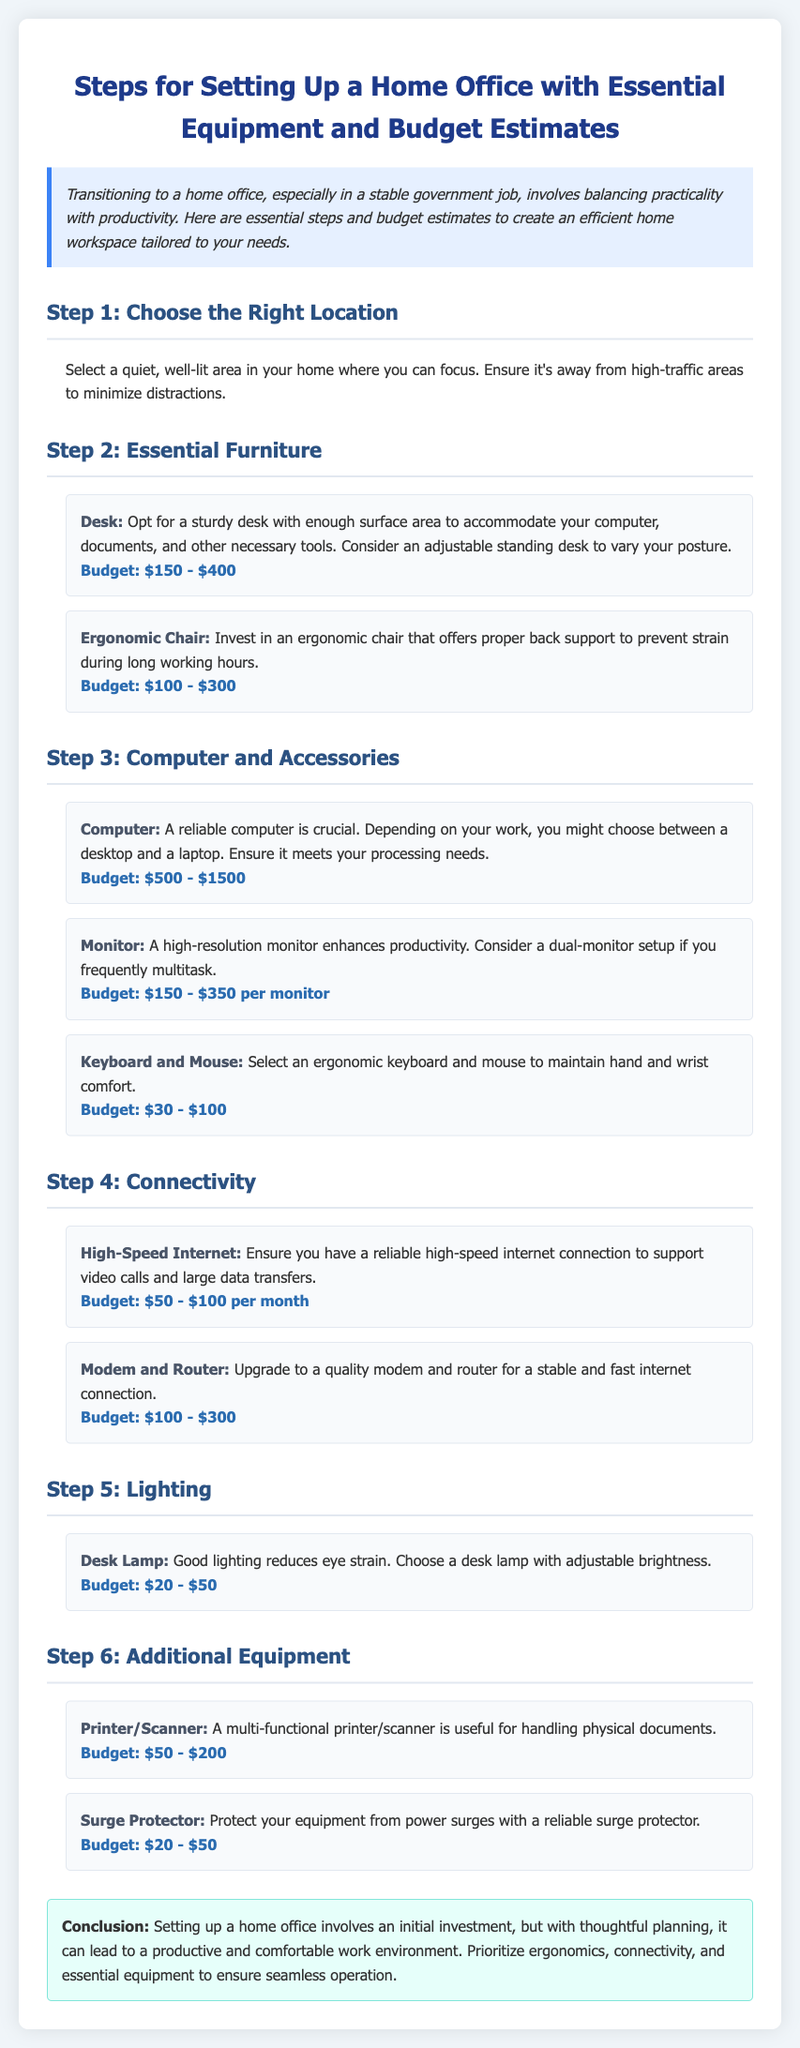what is the budget range for a desk? The budget for a desk is specified in the document under Step 2: Essential Furniture.
Answer: $150 - $400 what essential furniture is mentioned in Step 2? The document lists desk and ergonomic chair as essential furniture.
Answer: Desk, Ergonomic Chair how much can a high-speed internet connection cost per month? The budget for high-speed internet is provided in Step 4: Connectivity.
Answer: $50 - $100 per month what is the purpose of a surge protector? The document states its purpose in Step 6: Additional Equipment as protection from power surges.
Answer: Protect equipment what is one recommendation for lighting in the home office? The document advises choosing a desk lamp with adjustable brightness under Step 5: Lighting.
Answer: Desk Lamp what is the total budget estimate range for a reliable computer? The budget for a computer is noted in Step 3: Computer and Accessories.
Answer: $500 - $1500 what item is recommended for connectivity? The document mentions high-speed internet and modem/router in Step 4: Connectivity.
Answer: High-Speed Internet which step recommends investing in an ergonomic chair? The recommendation for an ergonomic chair is found in Step 2: Essential Furniture.
Answer: Step 2 what should you prioritize for an efficient home workspace? The conclusion emphasizes prioritizing ergonomics, connectivity, and essential equipment.
Answer: Ergonomics, Connectivity, Essential Equipment 